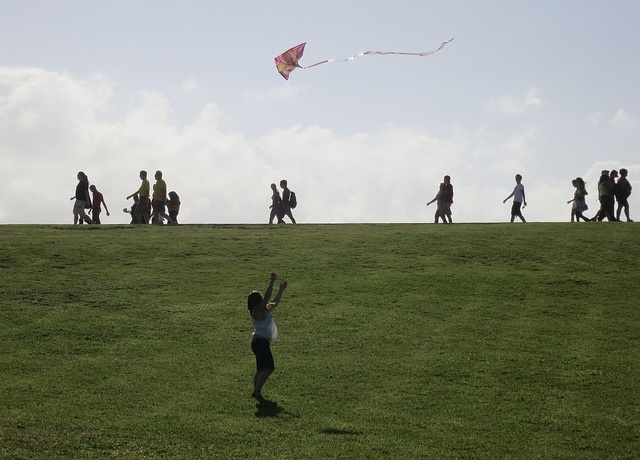Describe the objects in this image and their specific colors. I can see people in lightgray, black, darkgreen, and gray tones, people in lightgray, black, darkgreen, and gray tones, people in lightgray, black, gray, and darkgray tones, kite in lightgray, brown, and darkgray tones, and people in lightgray, black, gray, and darkgray tones in this image. 